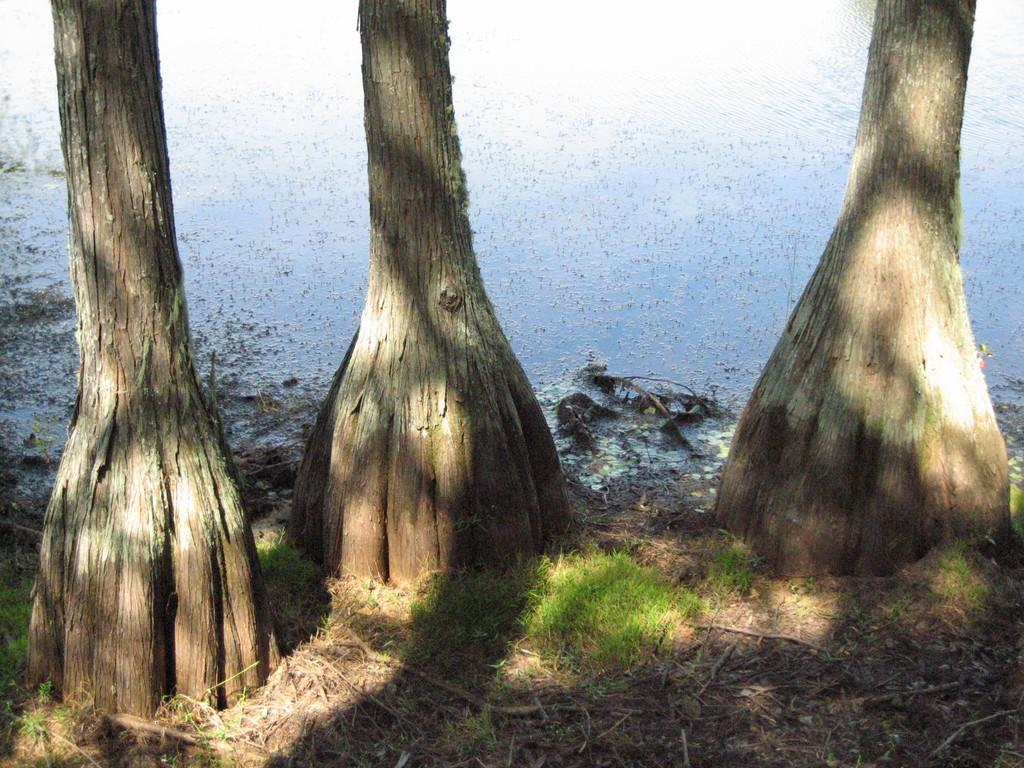What objects are present in the image? There are three trunks in the image. What can be seen at the bottom of the image? The ground is visible at the bottom of the image. What type of vegetation is present on the ground? There is grass on the ground. What is visible in the background of the image? There is water visible in the background of the image. What type of toothbrush design can be seen on the trunks in the image? There is no toothbrush or any design related to it present on the trunks in the image. 